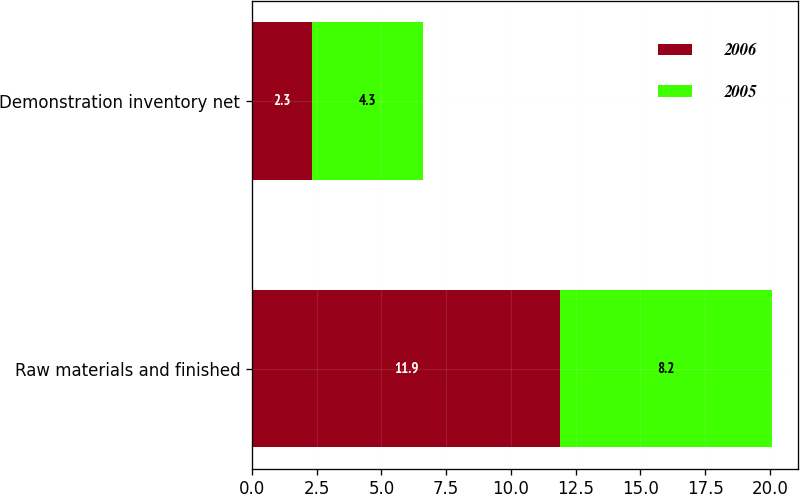<chart> <loc_0><loc_0><loc_500><loc_500><stacked_bar_chart><ecel><fcel>Raw materials and finished<fcel>Demonstration inventory net<nl><fcel>2006<fcel>11.9<fcel>2.3<nl><fcel>2005<fcel>8.2<fcel>4.3<nl></chart> 